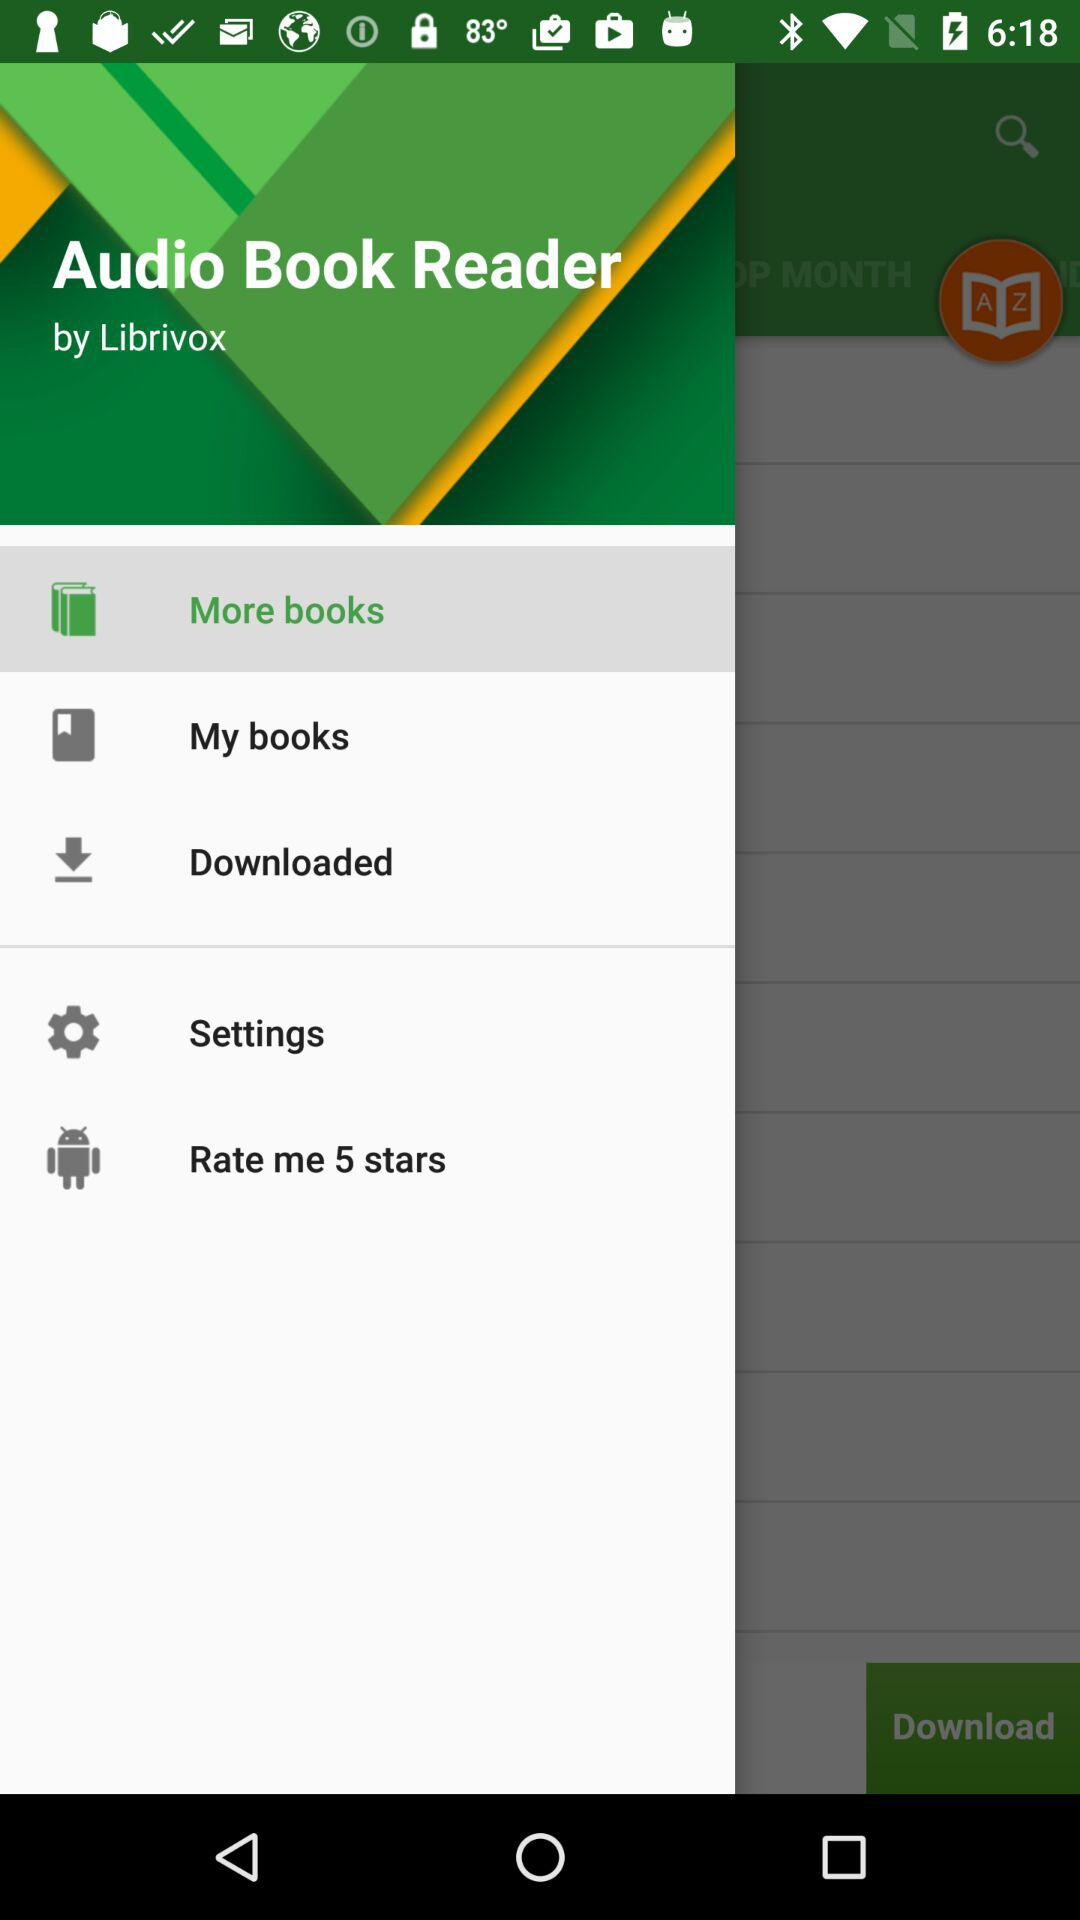Which item is selected? The selected item is "More books". 